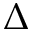Convert formula to latex. <formula><loc_0><loc_0><loc_500><loc_500>\Delta</formula> 